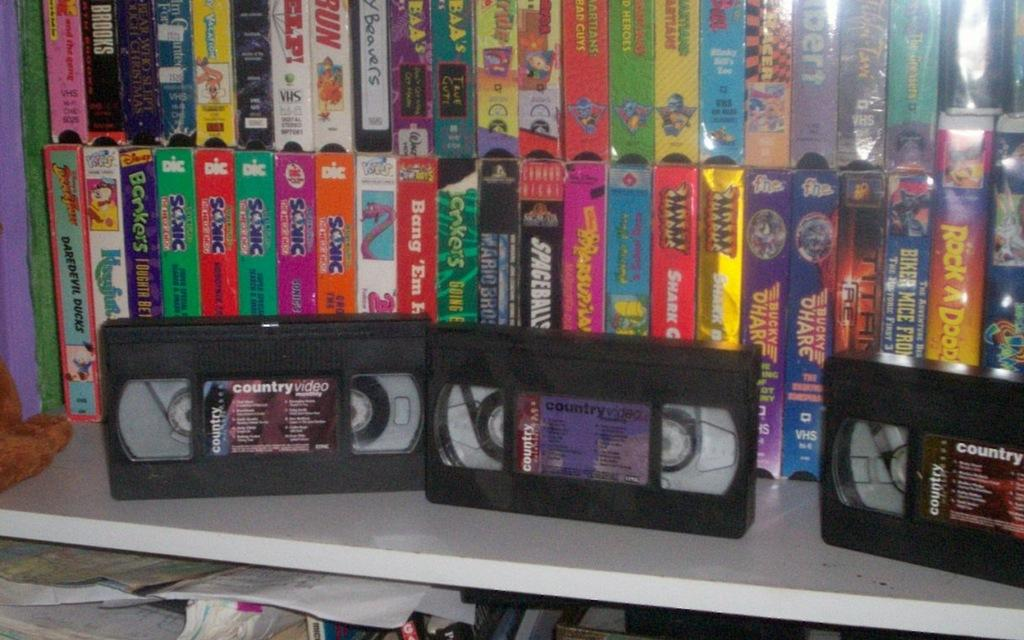Provide a one-sentence caption for the provided image. A bunch of all videos sitting on a white shelf. 